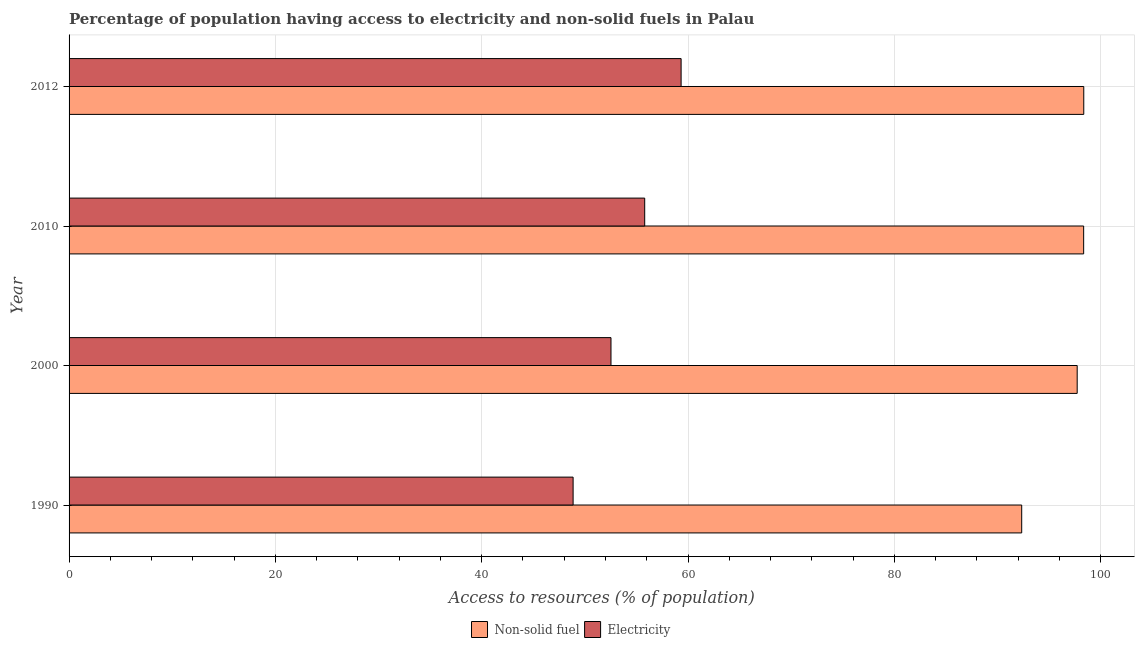How many groups of bars are there?
Provide a short and direct response. 4. Are the number of bars on each tick of the Y-axis equal?
Offer a terse response. Yes. What is the label of the 2nd group of bars from the top?
Provide a succinct answer. 2010. What is the percentage of population having access to electricity in 2010?
Offer a terse response. 55.8. Across all years, what is the maximum percentage of population having access to non-solid fuel?
Your response must be concise. 98.36. Across all years, what is the minimum percentage of population having access to non-solid fuel?
Give a very brief answer. 92.34. In which year was the percentage of population having access to non-solid fuel maximum?
Your response must be concise. 2012. What is the total percentage of population having access to non-solid fuel in the graph?
Offer a very short reply. 386.78. What is the difference between the percentage of population having access to non-solid fuel in 2010 and that in 2012?
Your answer should be compact. -0.01. What is the difference between the percentage of population having access to non-solid fuel in 2000 and the percentage of population having access to electricity in 2012?
Make the answer very short. 38.39. What is the average percentage of population having access to non-solid fuel per year?
Make the answer very short. 96.69. In the year 2000, what is the difference between the percentage of population having access to non-solid fuel and percentage of population having access to electricity?
Give a very brief answer. 45.19. What is the ratio of the percentage of population having access to non-solid fuel in 1990 to that in 2012?
Ensure brevity in your answer.  0.94. Is the percentage of population having access to non-solid fuel in 1990 less than that in 2012?
Provide a short and direct response. Yes. Is the difference between the percentage of population having access to electricity in 1990 and 2000 greater than the difference between the percentage of population having access to non-solid fuel in 1990 and 2000?
Ensure brevity in your answer.  Yes. What is the difference between the highest and the lowest percentage of population having access to non-solid fuel?
Offer a terse response. 6.02. Is the sum of the percentage of population having access to electricity in 2000 and 2010 greater than the maximum percentage of population having access to non-solid fuel across all years?
Keep it short and to the point. Yes. What does the 2nd bar from the top in 2010 represents?
Your answer should be very brief. Non-solid fuel. What does the 1st bar from the bottom in 2000 represents?
Make the answer very short. Non-solid fuel. How many years are there in the graph?
Provide a short and direct response. 4. What is the difference between two consecutive major ticks on the X-axis?
Your response must be concise. 20. Are the values on the major ticks of X-axis written in scientific E-notation?
Give a very brief answer. No. Does the graph contain grids?
Offer a very short reply. Yes. Where does the legend appear in the graph?
Provide a succinct answer. Bottom center. How many legend labels are there?
Provide a short and direct response. 2. What is the title of the graph?
Give a very brief answer. Percentage of population having access to electricity and non-solid fuels in Palau. What is the label or title of the X-axis?
Offer a very short reply. Access to resources (% of population). What is the Access to resources (% of population) of Non-solid fuel in 1990?
Make the answer very short. 92.34. What is the Access to resources (% of population) of Electricity in 1990?
Your response must be concise. 48.86. What is the Access to resources (% of population) of Non-solid fuel in 2000?
Provide a short and direct response. 97.72. What is the Access to resources (% of population) of Electricity in 2000?
Your answer should be very brief. 52.53. What is the Access to resources (% of population) in Non-solid fuel in 2010?
Your answer should be compact. 98.35. What is the Access to resources (% of population) of Electricity in 2010?
Provide a succinct answer. 55.8. What is the Access to resources (% of population) of Non-solid fuel in 2012?
Keep it short and to the point. 98.36. What is the Access to resources (% of population) in Electricity in 2012?
Keep it short and to the point. 59.33. Across all years, what is the maximum Access to resources (% of population) of Non-solid fuel?
Make the answer very short. 98.36. Across all years, what is the maximum Access to resources (% of population) in Electricity?
Provide a short and direct response. 59.33. Across all years, what is the minimum Access to resources (% of population) in Non-solid fuel?
Ensure brevity in your answer.  92.34. Across all years, what is the minimum Access to resources (% of population) in Electricity?
Your response must be concise. 48.86. What is the total Access to resources (% of population) of Non-solid fuel in the graph?
Keep it short and to the point. 386.78. What is the total Access to resources (% of population) of Electricity in the graph?
Your answer should be very brief. 216.52. What is the difference between the Access to resources (% of population) of Non-solid fuel in 1990 and that in 2000?
Ensure brevity in your answer.  -5.38. What is the difference between the Access to resources (% of population) in Electricity in 1990 and that in 2000?
Make the answer very short. -3.67. What is the difference between the Access to resources (% of population) in Non-solid fuel in 1990 and that in 2010?
Keep it short and to the point. -6.01. What is the difference between the Access to resources (% of population) in Electricity in 1990 and that in 2010?
Offer a terse response. -6.94. What is the difference between the Access to resources (% of population) in Non-solid fuel in 1990 and that in 2012?
Your response must be concise. -6.02. What is the difference between the Access to resources (% of population) in Electricity in 1990 and that in 2012?
Provide a succinct answer. -10.47. What is the difference between the Access to resources (% of population) of Non-solid fuel in 2000 and that in 2010?
Offer a very short reply. -0.63. What is the difference between the Access to resources (% of population) of Electricity in 2000 and that in 2010?
Your response must be concise. -3.27. What is the difference between the Access to resources (% of population) of Non-solid fuel in 2000 and that in 2012?
Your answer should be very brief. -0.64. What is the difference between the Access to resources (% of population) of Electricity in 2000 and that in 2012?
Your answer should be very brief. -6.8. What is the difference between the Access to resources (% of population) of Non-solid fuel in 2010 and that in 2012?
Your answer should be compact. -0.01. What is the difference between the Access to resources (% of population) in Electricity in 2010 and that in 2012?
Offer a very short reply. -3.53. What is the difference between the Access to resources (% of population) in Non-solid fuel in 1990 and the Access to resources (% of population) in Electricity in 2000?
Make the answer very short. 39.81. What is the difference between the Access to resources (% of population) of Non-solid fuel in 1990 and the Access to resources (% of population) of Electricity in 2010?
Your response must be concise. 36.54. What is the difference between the Access to resources (% of population) in Non-solid fuel in 1990 and the Access to resources (% of population) in Electricity in 2012?
Offer a terse response. 33.02. What is the difference between the Access to resources (% of population) in Non-solid fuel in 2000 and the Access to resources (% of population) in Electricity in 2010?
Keep it short and to the point. 41.92. What is the difference between the Access to resources (% of population) in Non-solid fuel in 2000 and the Access to resources (% of population) in Electricity in 2012?
Provide a succinct answer. 38.39. What is the difference between the Access to resources (% of population) in Non-solid fuel in 2010 and the Access to resources (% of population) in Electricity in 2012?
Offer a very short reply. 39.02. What is the average Access to resources (% of population) of Non-solid fuel per year?
Give a very brief answer. 96.69. What is the average Access to resources (% of population) in Electricity per year?
Offer a very short reply. 54.13. In the year 1990, what is the difference between the Access to resources (% of population) in Non-solid fuel and Access to resources (% of population) in Electricity?
Your response must be concise. 43.49. In the year 2000, what is the difference between the Access to resources (% of population) in Non-solid fuel and Access to resources (% of population) in Electricity?
Provide a short and direct response. 45.19. In the year 2010, what is the difference between the Access to resources (% of population) of Non-solid fuel and Access to resources (% of population) of Electricity?
Ensure brevity in your answer.  42.55. In the year 2012, what is the difference between the Access to resources (% of population) of Non-solid fuel and Access to resources (% of population) of Electricity?
Offer a terse response. 39.03. What is the ratio of the Access to resources (% of population) of Non-solid fuel in 1990 to that in 2000?
Ensure brevity in your answer.  0.94. What is the ratio of the Access to resources (% of population) in Electricity in 1990 to that in 2000?
Your answer should be very brief. 0.93. What is the ratio of the Access to resources (% of population) of Non-solid fuel in 1990 to that in 2010?
Your answer should be very brief. 0.94. What is the ratio of the Access to resources (% of population) of Electricity in 1990 to that in 2010?
Offer a terse response. 0.88. What is the ratio of the Access to resources (% of population) in Non-solid fuel in 1990 to that in 2012?
Make the answer very short. 0.94. What is the ratio of the Access to resources (% of population) of Electricity in 1990 to that in 2012?
Make the answer very short. 0.82. What is the ratio of the Access to resources (% of population) of Non-solid fuel in 2000 to that in 2010?
Ensure brevity in your answer.  0.99. What is the ratio of the Access to resources (% of population) of Electricity in 2000 to that in 2010?
Your answer should be compact. 0.94. What is the ratio of the Access to resources (% of population) in Non-solid fuel in 2000 to that in 2012?
Provide a succinct answer. 0.99. What is the ratio of the Access to resources (% of population) in Electricity in 2000 to that in 2012?
Make the answer very short. 0.89. What is the ratio of the Access to resources (% of population) of Non-solid fuel in 2010 to that in 2012?
Offer a very short reply. 1. What is the ratio of the Access to resources (% of population) in Electricity in 2010 to that in 2012?
Give a very brief answer. 0.94. What is the difference between the highest and the second highest Access to resources (% of population) in Non-solid fuel?
Give a very brief answer. 0.01. What is the difference between the highest and the second highest Access to resources (% of population) of Electricity?
Make the answer very short. 3.53. What is the difference between the highest and the lowest Access to resources (% of population) of Non-solid fuel?
Keep it short and to the point. 6.02. What is the difference between the highest and the lowest Access to resources (% of population) in Electricity?
Provide a short and direct response. 10.47. 